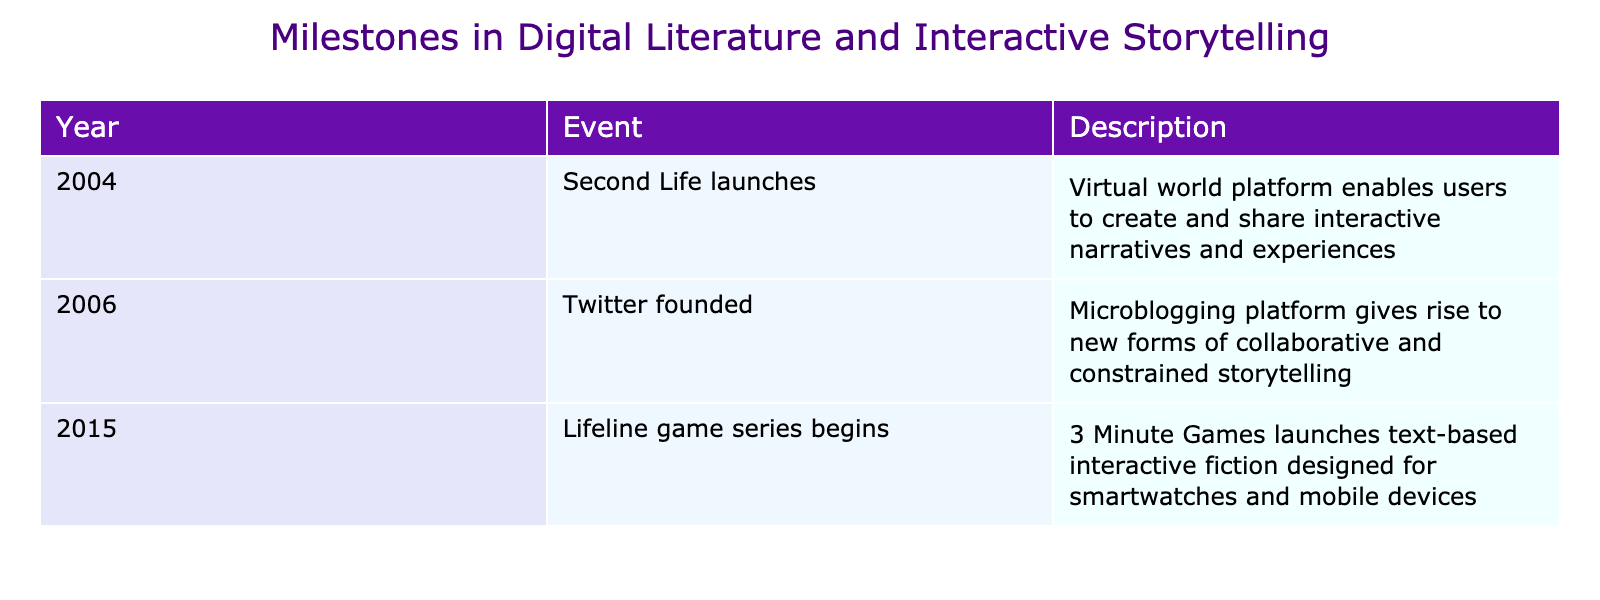What year did Second Life launch? The table provides a clear year for each event listed. By looking for "Second Life" in the Event column, I see it corresponds to the year 2004.
Answer: 2004 Which event occurred in 2006? From the Event column, I can see that the event corresponding to 2006 is "Twitter founded."
Answer: Twitter founded How many years apart are Second Life and Lifeline game series launches? The years for Second Life (2004) and Lifeline game series (2015) are noted in the Year column. The difference between 2015 and 2004 is 11 years.
Answer: 11 years Was Lifeline the first game series mentioned in the table? To determine if Lifeline is first, I check the order of events. The table shows the events in chronological order, and Lifeline appears third. Therefore, it is not the first.
Answer: No How many total events are documented in the table? The table lists three distinct events. By counting the entries under the Event column, I find the total is three.
Answer: 3 What is the significance of Twitter's founding in the context of storytelling? The table notes Twitter's founding as a development that led to new forms of storytelling. It signifies that Twitter allowed collaborative narratives within character limits, which changes how stories are shared.
Answer: Collaborative storytelling Can you describe the overall trend in the years listed for the milestones? Reviewing the years (2004, 2006, 2015), I observe a general progression toward more modern and mobile-focused digital storytelling platforms, indicating growth in technology and audience engagement.
Answer: Progressing towards modern storytelling Which event represents the earliest milestone in digital literature? Analyzing the Year column, Second Life in 2004 is the earliest event listed, marking a significant starting point for interactive narratives.
Answer: Second Life launches 